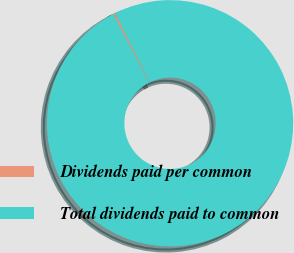<chart> <loc_0><loc_0><loc_500><loc_500><pie_chart><fcel>Dividends paid per common<fcel>Total dividends paid to common<nl><fcel>0.26%<fcel>99.74%<nl></chart> 